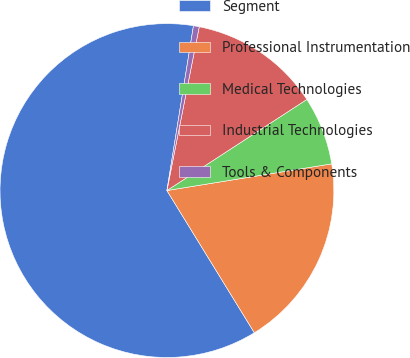<chart> <loc_0><loc_0><loc_500><loc_500><pie_chart><fcel>Segment<fcel>Professional Instrumentation<fcel>Medical Technologies<fcel>Industrial Technologies<fcel>Tools & Components<nl><fcel>61.31%<fcel>18.78%<fcel>6.63%<fcel>12.71%<fcel>0.56%<nl></chart> 